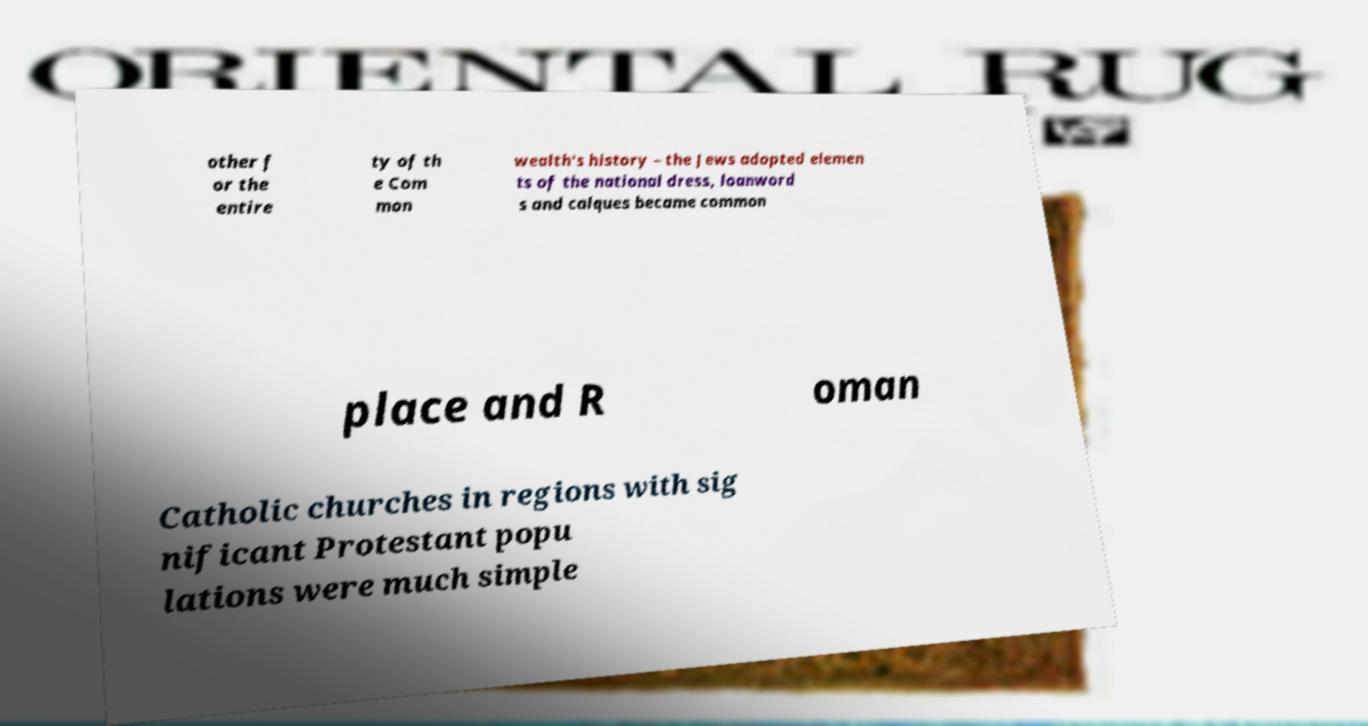What messages or text are displayed in this image? I need them in a readable, typed format. other f or the entire ty of th e Com mon wealth's history – the Jews adopted elemen ts of the national dress, loanword s and calques became common place and R oman Catholic churches in regions with sig nificant Protestant popu lations were much simple 